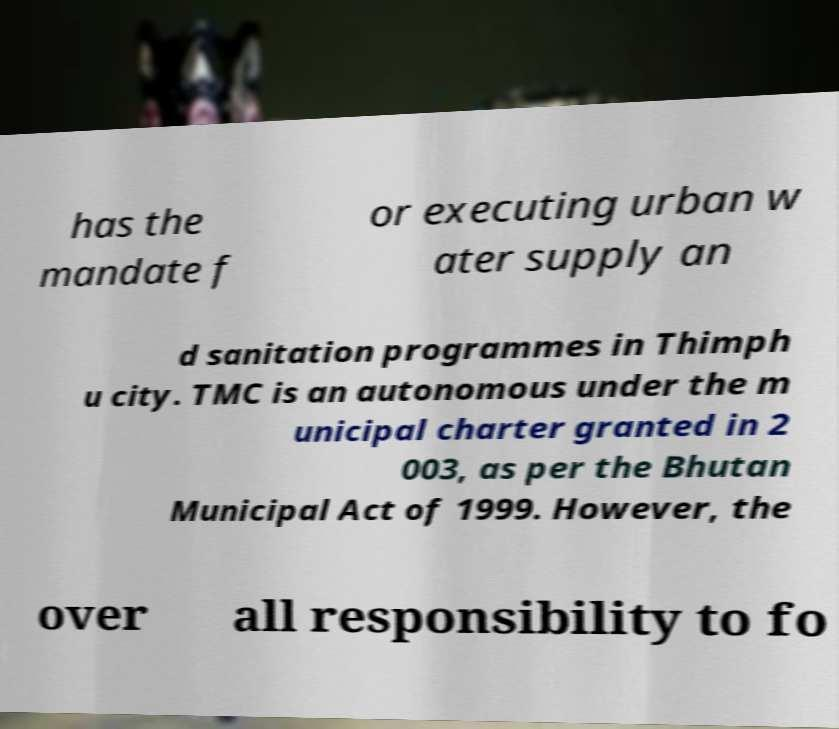There's text embedded in this image that I need extracted. Can you transcribe it verbatim? has the mandate f or executing urban w ater supply an d sanitation programmes in Thimph u city. TMC is an autonomous under the m unicipal charter granted in 2 003, as per the Bhutan Municipal Act of 1999. However, the over all responsibility to fo 